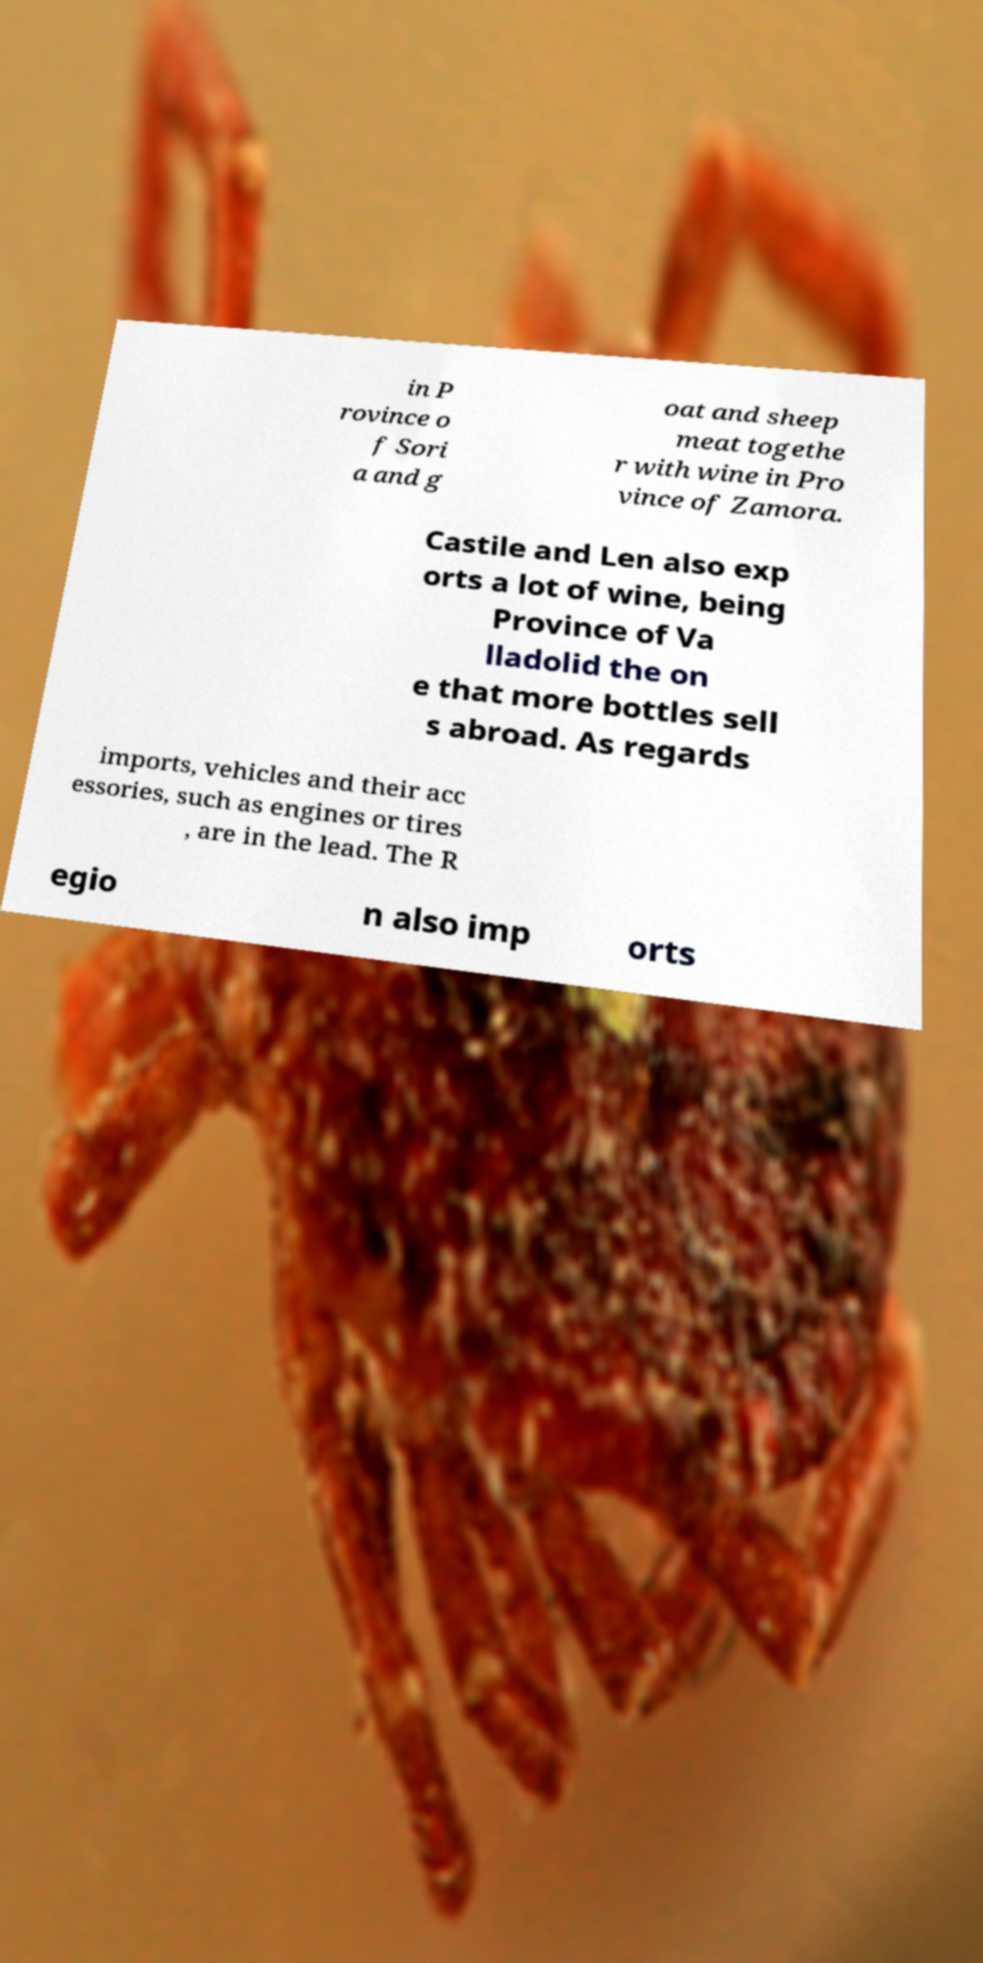What messages or text are displayed in this image? I need them in a readable, typed format. in P rovince o f Sori a and g oat and sheep meat togethe r with wine in Pro vince of Zamora. Castile and Len also exp orts a lot of wine, being Province of Va lladolid the on e that more bottles sell s abroad. As regards imports, vehicles and their acc essories, such as engines or tires , are in the lead. The R egio n also imp orts 